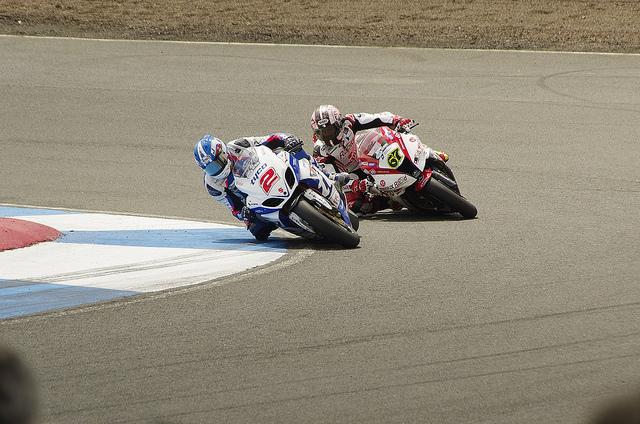Are they about to fall?
Concise answer only. No. Are there knees touching the road?
Quick response, please. Yes. What number is on the blue bike?
Quick response, please. 2. 